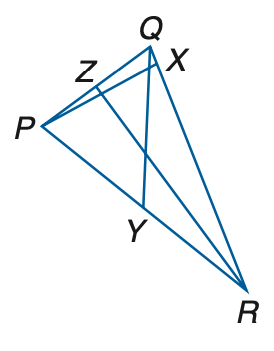Answer the mathemtical geometry problem and directly provide the correct option letter.
Question: In \triangle P Q R, Z Q = 3 a - 11, Z P = a + 5, P Y = 2 c - 1, Y R = 4 c - 11, m \angle P R Z = 4 b - 17, m \angle Z R Q = 3 b - 4, m \angle Q Y R = 7 b + 6, and m \angle P X R = 2 a + 10. Find P R if Q Y is a median.
Choices: A: 14 B: 16 C: 18 D: 20 C 